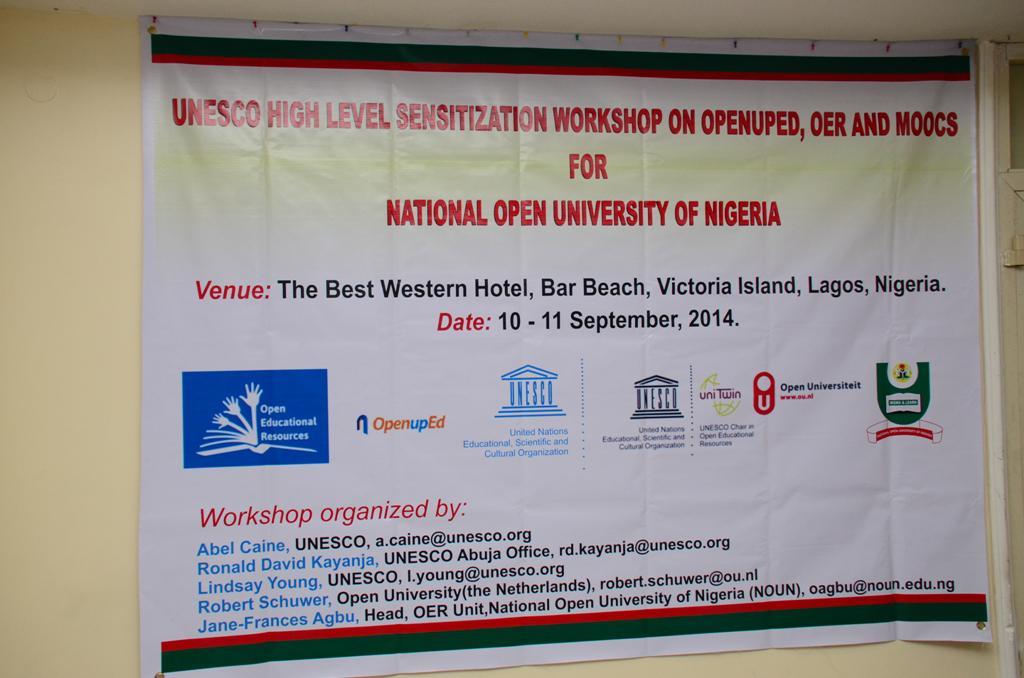Where is the venue?
Your answer should be compact. The best western hotel. What date is the event?
Your answer should be compact. 10 - 11 september, 2014. 